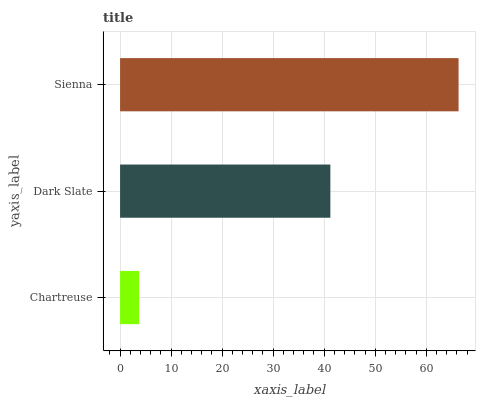Is Chartreuse the minimum?
Answer yes or no. Yes. Is Sienna the maximum?
Answer yes or no. Yes. Is Dark Slate the minimum?
Answer yes or no. No. Is Dark Slate the maximum?
Answer yes or no. No. Is Dark Slate greater than Chartreuse?
Answer yes or no. Yes. Is Chartreuse less than Dark Slate?
Answer yes or no. Yes. Is Chartreuse greater than Dark Slate?
Answer yes or no. No. Is Dark Slate less than Chartreuse?
Answer yes or no. No. Is Dark Slate the high median?
Answer yes or no. Yes. Is Dark Slate the low median?
Answer yes or no. Yes. Is Chartreuse the high median?
Answer yes or no. No. Is Chartreuse the low median?
Answer yes or no. No. 